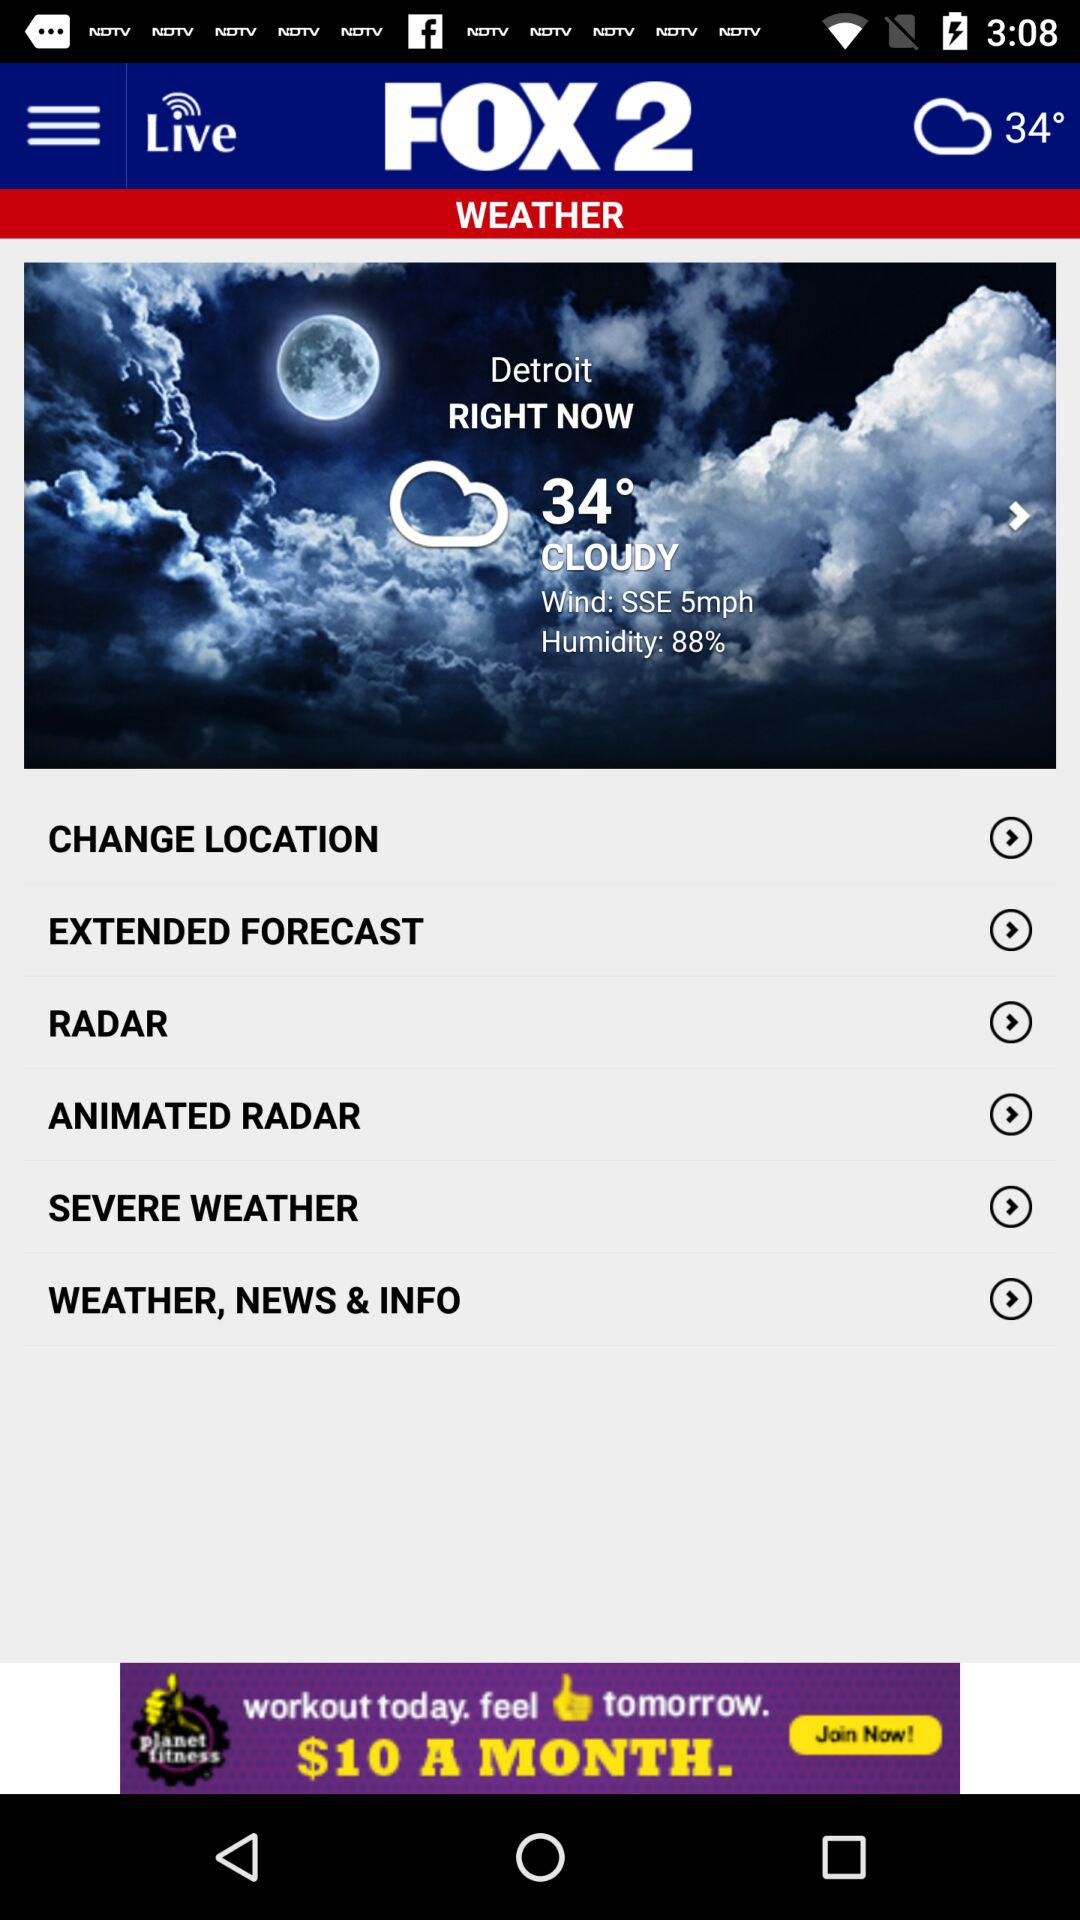Will it be cloudy again tomorrow?
When the provided information is insufficient, respond with <no answer>. <no answer> 